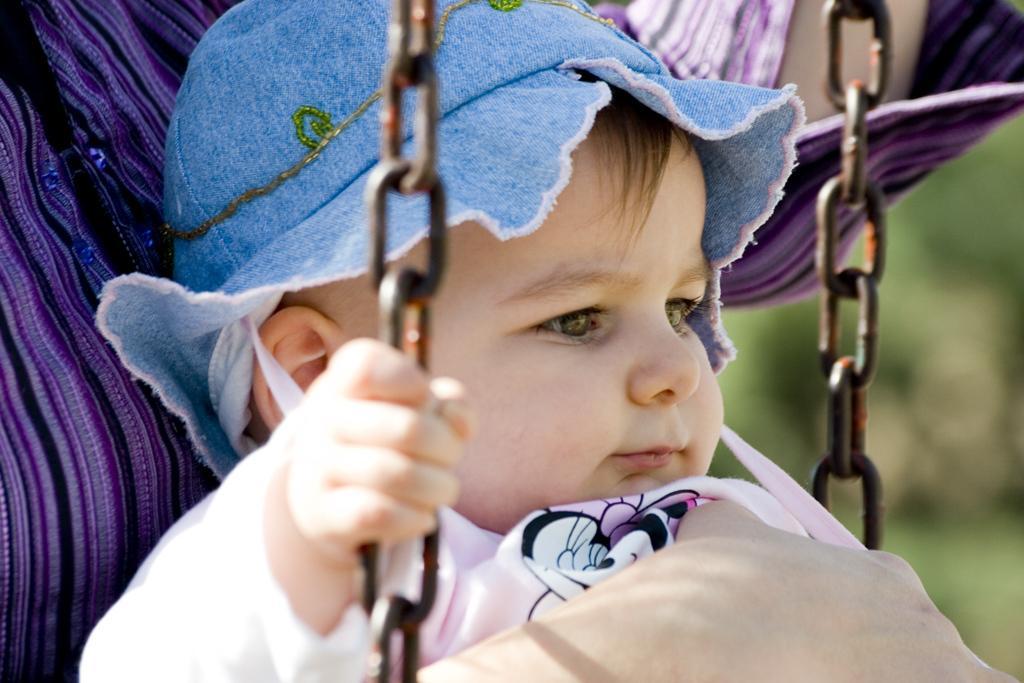How would you summarize this image in a sentence or two? In this image I can see a baby sitting on the swing and wearing blue cap. Baby is wearing colorful dress and background is blurred. 